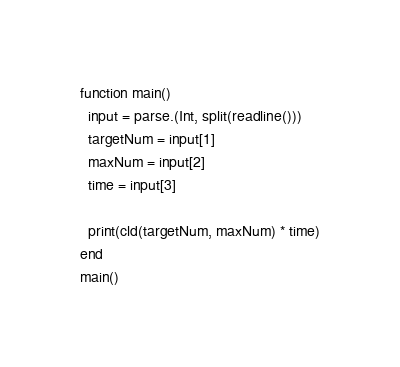<code> <loc_0><loc_0><loc_500><loc_500><_Julia_>function main()
  input = parse.(Int, split(readline()))
  targetNum = input[1]
  maxNum = input[2]
  time = input[3]
  
  print(cld(targetNum, maxNum) * time)
end
main()</code> 